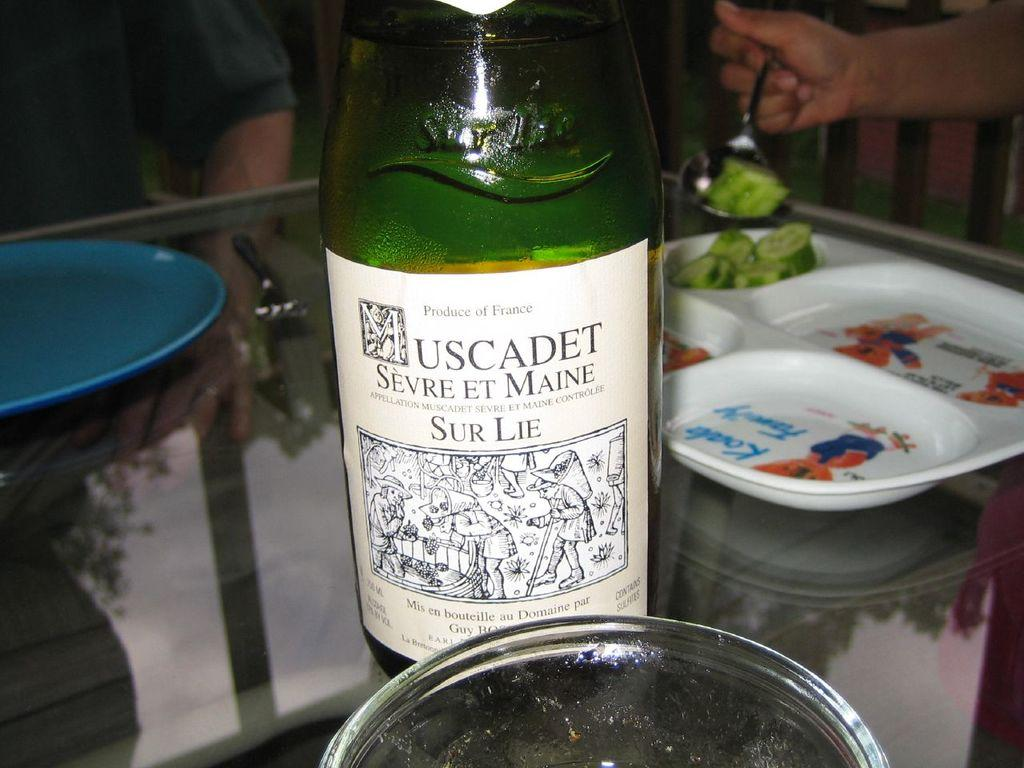<image>
Relay a brief, clear account of the picture shown. A green bottle of Auscadet Svre et Main Sur Lie alcohol with a white tag. 